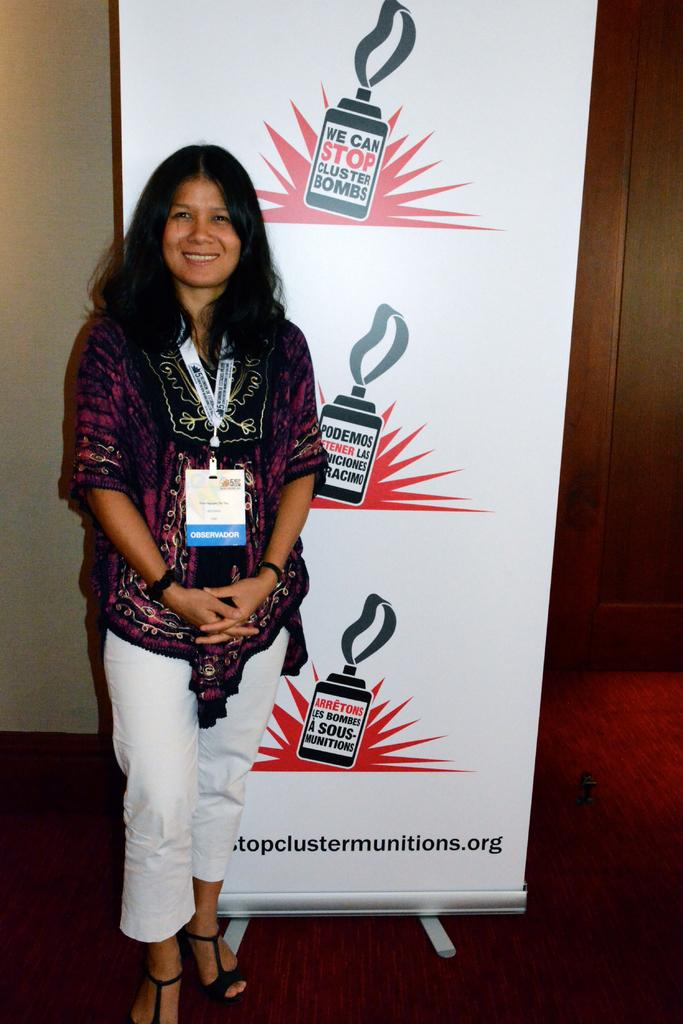Who is present in the image? There is a woman in the image. What is the woman doing in the image? The woman is standing on the floor and at a hoarding. Can you describe the woman's attire? The woman is wearing an ID card around her neck. What can be seen in the background of the image? There is a wall in the image. What type of poison is the woman holding in the image? There is no poison present in the image; the woman is wearing an ID card around her neck. Can you describe the potato that the woman is holding in the image? There is no potato present in the image; the woman is standing at a hoarding. 